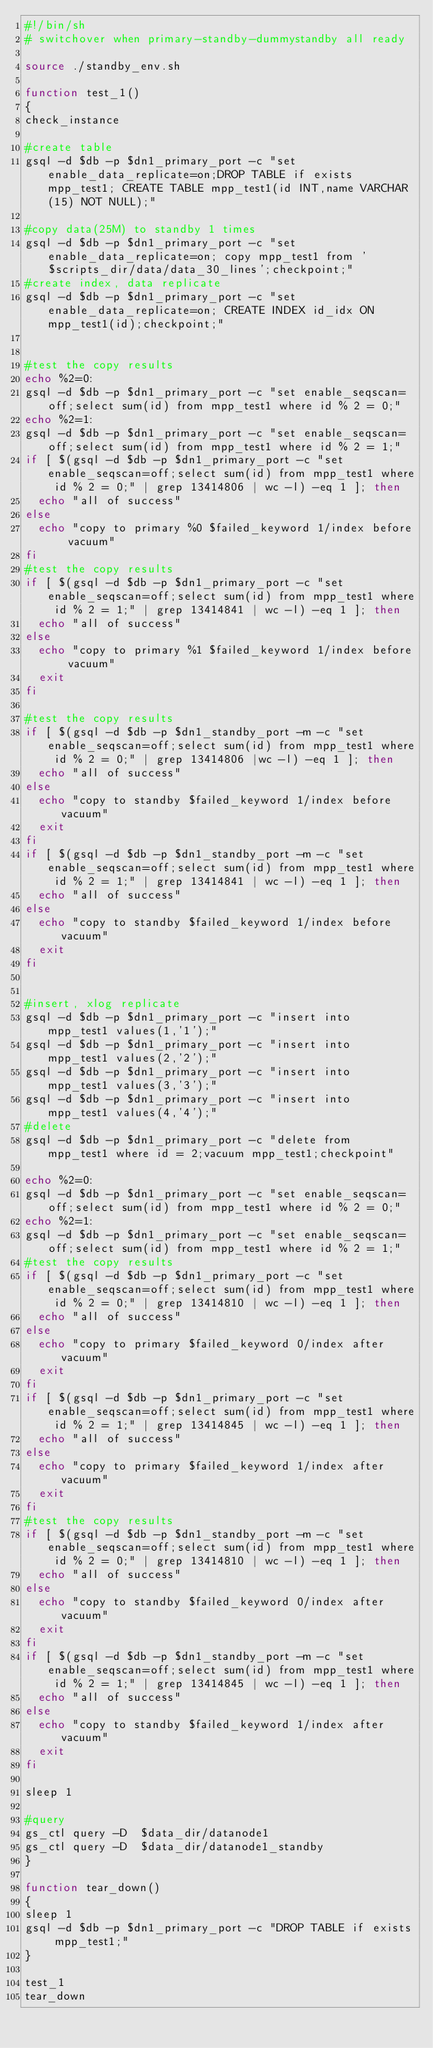<code> <loc_0><loc_0><loc_500><loc_500><_Bash_>#!/bin/sh
# switchover when primary-standby-dummystandby all ready

source ./standby_env.sh

function test_1()
{
check_instance

#create table
gsql -d $db -p $dn1_primary_port -c "set enable_data_replicate=on;DROP TABLE if exists mpp_test1; CREATE TABLE mpp_test1(id INT,name VARCHAR(15) NOT NULL);"

#copy data(25M) to standby 1 times
gsql -d $db -p $dn1_primary_port -c "set enable_data_replicate=on; copy mpp_test1 from '$scripts_dir/data/data_30_lines';checkpoint;"
#create index, data replicate
gsql -d $db -p $dn1_primary_port -c "set enable_data_replicate=on; CREATE INDEX id_idx ON mpp_test1(id);checkpoint;"


#test the copy results
echo %2=0:
gsql -d $db -p $dn1_primary_port -c "set enable_seqscan=off;select sum(id) from mpp_test1 where id % 2 = 0;" 
echo %2=1:
gsql -d $db -p $dn1_primary_port -c "set enable_seqscan=off;select sum(id) from mpp_test1 where id % 2 = 1;"
if [ $(gsql -d $db -p $dn1_primary_port -c "set enable_seqscan=off;select sum(id) from mpp_test1 where id % 2 = 0;" | grep 13414806 | wc -l) -eq 1 ]; then
	echo "all of success"
else
	echo "copy to primary %0 $failed_keyword 1/index before vacuum"
fi
#test the copy results
if [ $(gsql -d $db -p $dn1_primary_port -c "set enable_seqscan=off;select sum(id) from mpp_test1 where id % 2 = 1;" | grep 13414841 | wc -l) -eq 1 ]; then
	echo "all of success"
else
	echo "copy to primary %1 $failed_keyword 1/index before vacuum"
	exit
fi

#test the copy results
if [ $(gsql -d $db -p $dn1_standby_port -m -c "set enable_seqscan=off;select sum(id) from mpp_test1 where id % 2 = 0;" | grep 13414806 |wc -l) -eq 1 ]; then
	echo "all of success"
else
	echo "copy to standby $failed_keyword 1/index before vacuum"
	exit
fi
if [ $(gsql -d $db -p $dn1_standby_port -m -c "set enable_seqscan=off;select sum(id) from mpp_test1 where id % 2 = 1;" | grep 13414841 | wc -l) -eq 1 ]; then
	echo "all of success"
else
	echo "copy to standby $failed_keyword 1/index before vacuum"
	exit
fi


#insert, xlog replicate
gsql -d $db -p $dn1_primary_port -c "insert into mpp_test1 values(1,'1');"
gsql -d $db -p $dn1_primary_port -c "insert into mpp_test1 values(2,'2');"
gsql -d $db -p $dn1_primary_port -c "insert into mpp_test1 values(3,'3');"
gsql -d $db -p $dn1_primary_port -c "insert into mpp_test1 values(4,'4');"
#delete
gsql -d $db -p $dn1_primary_port -c "delete from mpp_test1 where id = 2;vacuum mpp_test1;checkpoint"

echo %2=0:
gsql -d $db -p $dn1_primary_port -c "set enable_seqscan=off;select sum(id) from mpp_test1 where id % 2 = 0;"
echo %2=1:
gsql -d $db -p $dn1_primary_port -c "set enable_seqscan=off;select sum(id) from mpp_test1 where id % 2 = 1;"
#test the copy results
if [ $(gsql -d $db -p $dn1_primary_port -c "set enable_seqscan=off;select sum(id) from mpp_test1 where id % 2 = 0;" | grep 13414810 | wc -l) -eq 1 ]; then
	echo "all of success"
else
	echo "copy to primary $failed_keyword 0/index after vacuum"
	exit
fi
if [ $(gsql -d $db -p $dn1_primary_port -c "set enable_seqscan=off;select sum(id) from mpp_test1 where id % 2 = 1;" | grep 13414845 | wc -l) -eq 1 ]; then
	echo "all of success"
else
	echo "copy to primary $failed_keyword 1/index after vacuum"
	exit
fi
#test the copy results
if [ $(gsql -d $db -p $dn1_standby_port -m -c "set enable_seqscan=off;select sum(id) from mpp_test1 where id % 2 = 0;" | grep 13414810 | wc -l) -eq 1 ]; then
	echo "all of success"
else
	echo "copy to standby $failed_keyword 0/index after vacuum"
	exit
fi
if [ $(gsql -d $db -p $dn1_standby_port -m -c "set enable_seqscan=off;select sum(id) from mpp_test1 where id % 2 = 1;" | grep 13414845 | wc -l) -eq 1 ]; then
	echo "all of success"
else
	echo "copy to standby $failed_keyword 1/index after vacuum"
	exit
fi

sleep 1

#query
gs_ctl query -D  $data_dir/datanode1
gs_ctl query -D  $data_dir/datanode1_standby
}

function tear_down()
{
sleep 1
gsql -d $db -p $dn1_primary_port -c "DROP TABLE if exists mpp_test1;"
}

test_1
tear_down
</code> 